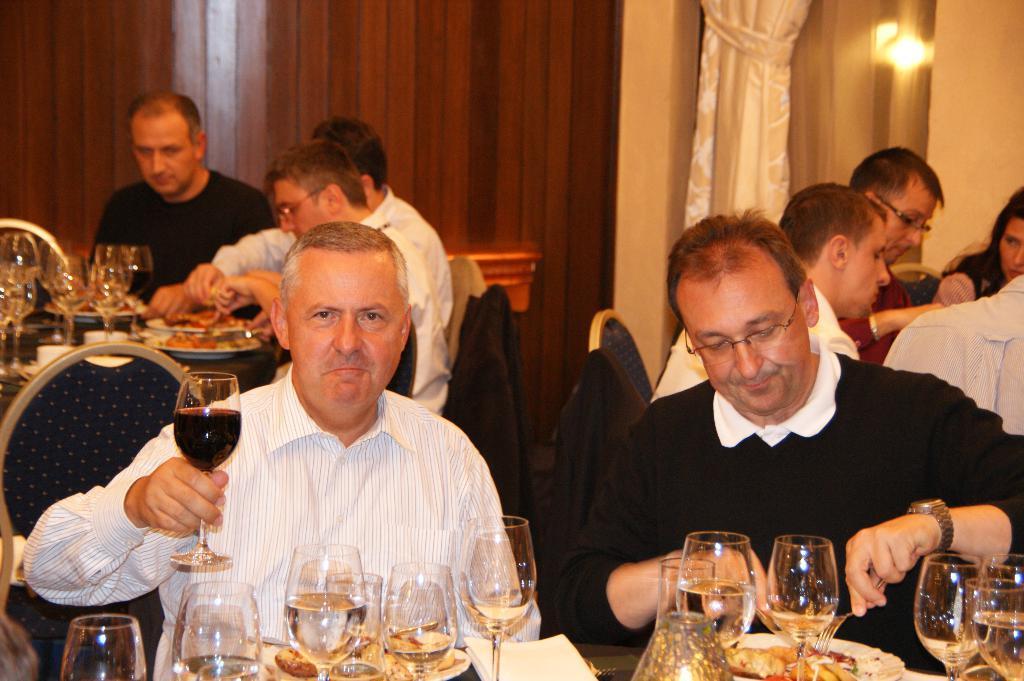Please provide a concise description of this image. To the left side of the image there is a person holding a wine glass in his hand. To the right side of the image there is a person wearing a black color sweater. In front of them there is a table on which there are glasses and other food items in plate. In the background of the image there are people sitting on chairs. There are glasses and other objects on the table. There is a wooden wall. To the right side of the image there is a white color curtain and a wall. 